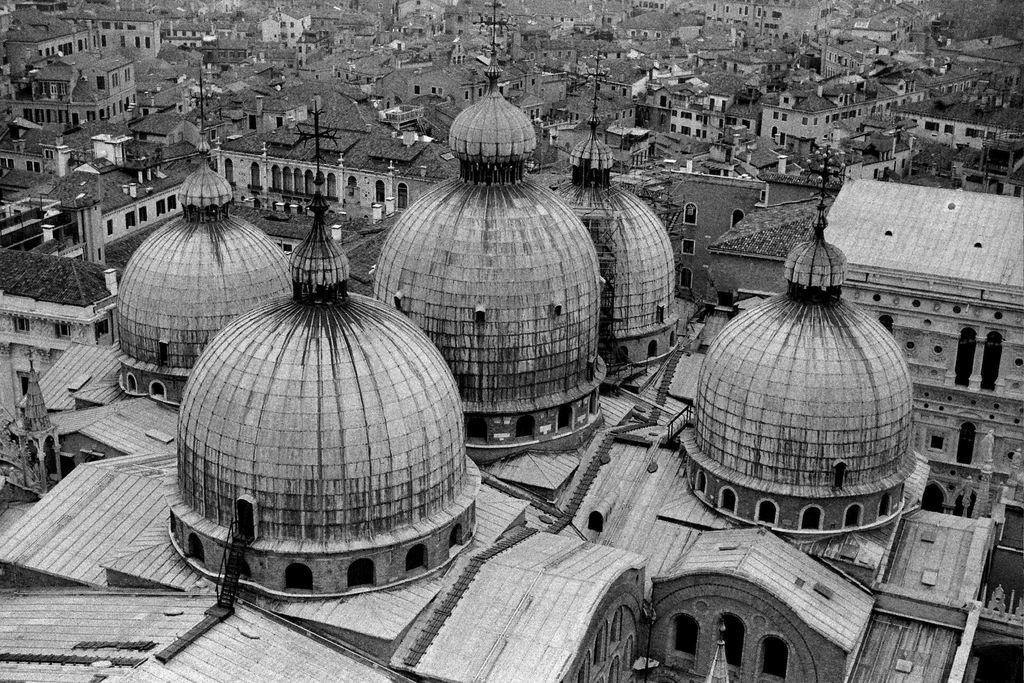Please provide a concise description of this image. In this image I can see the houses. I can also see the image is in black and white color. 